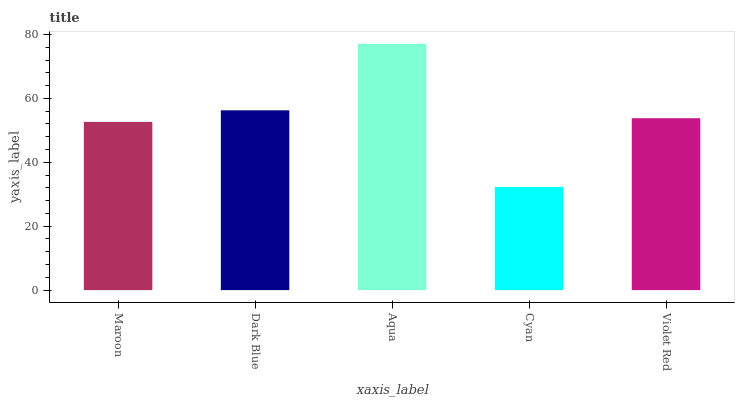Is Dark Blue the minimum?
Answer yes or no. No. Is Dark Blue the maximum?
Answer yes or no. No. Is Dark Blue greater than Maroon?
Answer yes or no. Yes. Is Maroon less than Dark Blue?
Answer yes or no. Yes. Is Maroon greater than Dark Blue?
Answer yes or no. No. Is Dark Blue less than Maroon?
Answer yes or no. No. Is Violet Red the high median?
Answer yes or no. Yes. Is Violet Red the low median?
Answer yes or no. Yes. Is Dark Blue the high median?
Answer yes or no. No. Is Cyan the low median?
Answer yes or no. No. 